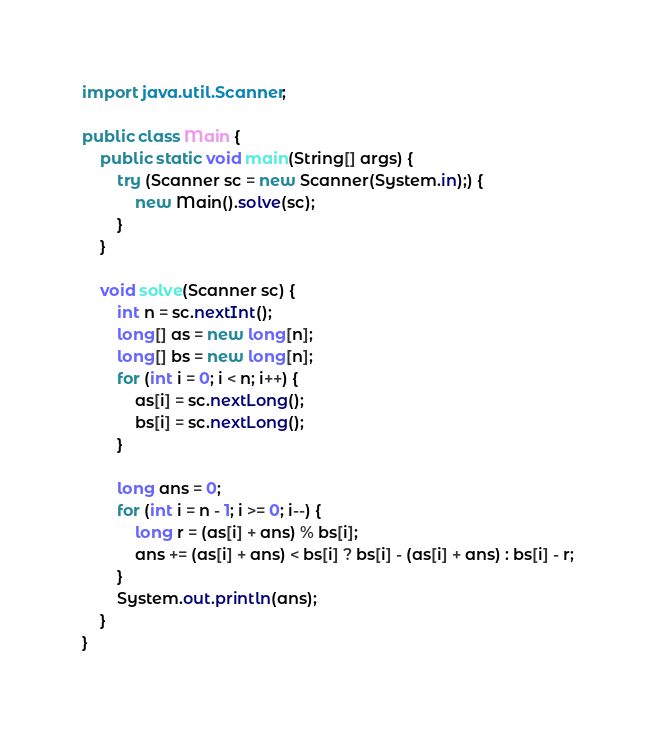Convert code to text. <code><loc_0><loc_0><loc_500><loc_500><_Java_>import java.util.Scanner;

public class Main {
    public static void main(String[] args) {
        try (Scanner sc = new Scanner(System.in);) {
            new Main().solve(sc);
        }
    }

    void solve(Scanner sc) {
        int n = sc.nextInt();
        long[] as = new long[n];
        long[] bs = new long[n];
        for (int i = 0; i < n; i++) {
            as[i] = sc.nextLong();
            bs[i] = sc.nextLong();
        }

        long ans = 0;
        for (int i = n - 1; i >= 0; i--) {
            long r = (as[i] + ans) % bs[i];
            ans += (as[i] + ans) < bs[i] ? bs[i] - (as[i] + ans) : bs[i] - r;
        }
        System.out.println(ans);
    }
}
</code> 